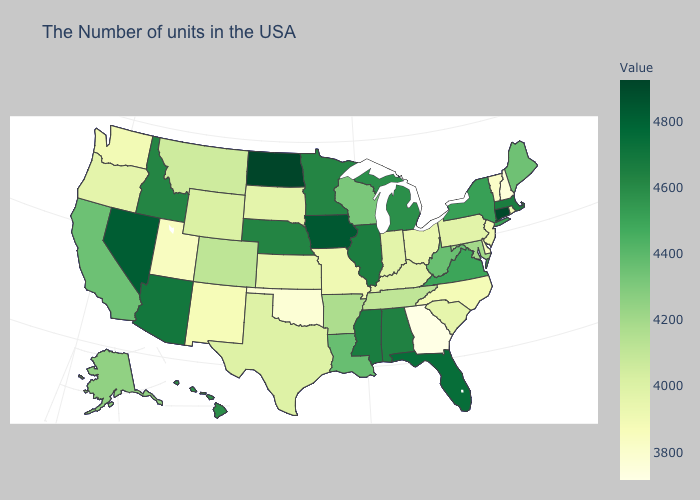Which states have the highest value in the USA?
Answer briefly. North Dakota. Among the states that border Arkansas , which have the highest value?
Write a very short answer. Mississippi. Does the map have missing data?
Keep it brief. No. Does New Hampshire have the lowest value in the Northeast?
Short answer required. Yes. Does New Mexico have the highest value in the USA?
Be succinct. No. 